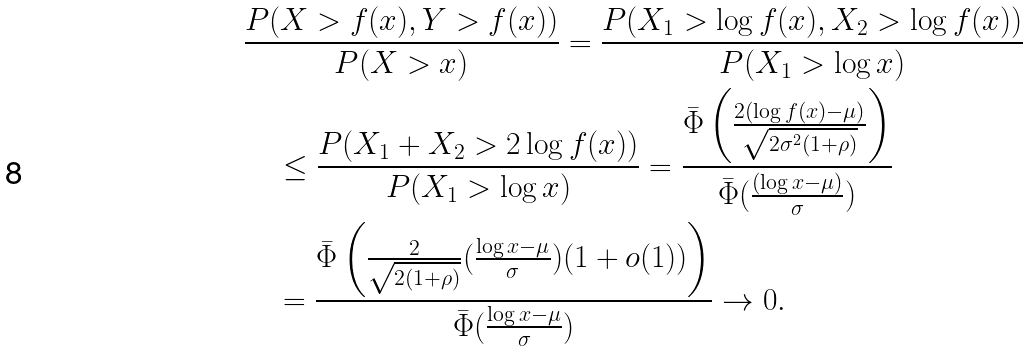Convert formula to latex. <formula><loc_0><loc_0><loc_500><loc_500>& \frac { P ( X > f ( x ) , Y > f ( x ) ) } { P ( X > x ) } = \frac { P ( X _ { 1 } > \log f ( x ) , X _ { 2 } > \log f ( x ) ) } { P ( X _ { 1 } > \log x ) } \\ & \quad \leq \frac { P ( X _ { 1 } + X _ { 2 } > 2 \log f ( x ) ) } { P ( X _ { 1 } > \log x ) } = \frac { \bar { \Phi } \left ( \frac { 2 ( \log f ( x ) - \mu ) } { \sqrt { 2 \sigma ^ { 2 } ( 1 + \rho ) } } \right ) } { \bar { \Phi } ( \frac { ( \log x - \mu ) } { \sigma } ) } \\ & \quad = \frac { \bar { \Phi } \left ( \frac { 2 } { \sqrt { 2 ( 1 + \rho ) } } ( \frac { \log x - \mu } { \sigma } ) ( 1 + o ( 1 ) ) \right ) } { \bar { \Phi } ( \frac { \log x - \mu } { \sigma } ) } \rightarrow 0 .</formula> 